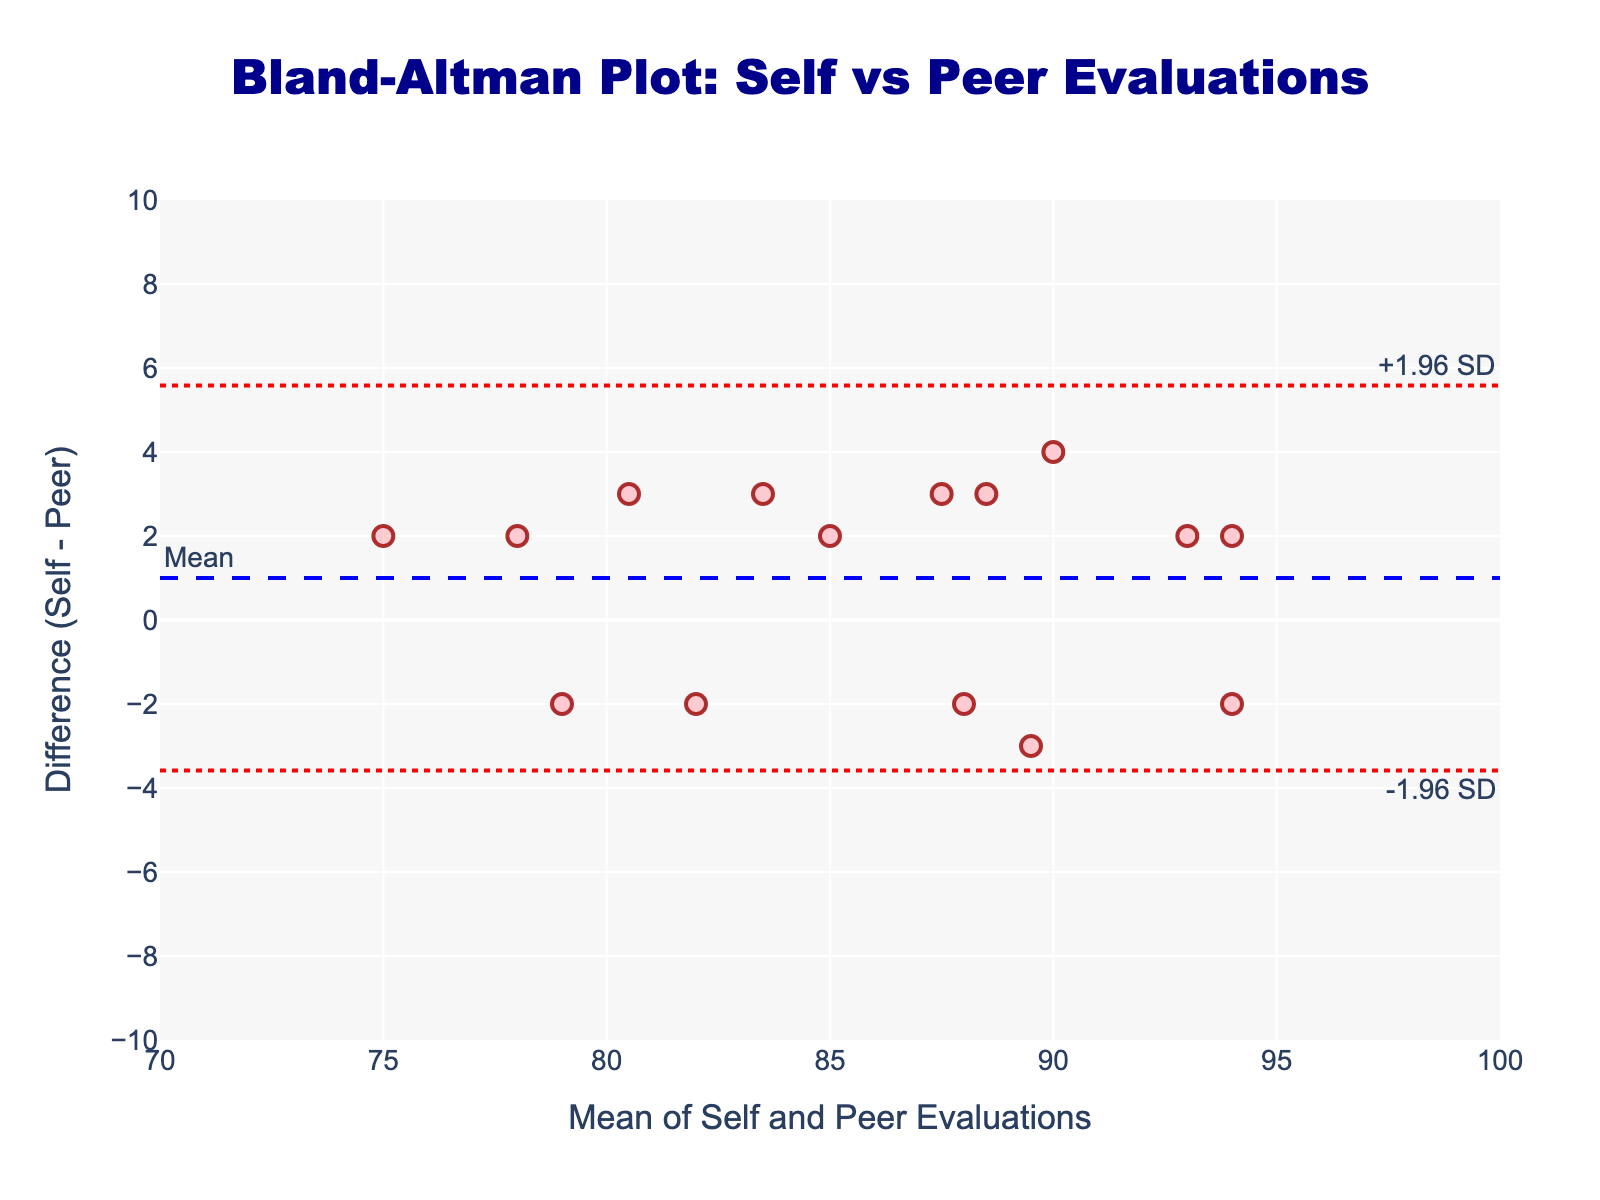What does the title of the plot say? The title is clearly written at the top of the plot, indicating what the plot is about. It says "Bland-Altman Plot: Self vs Peer Evaluations".
Answer: Bland-Altman Plot: Self vs Peer Evaluations What are the axes titles of the plot? The x-axis title is "Mean of Self and Peer Evaluations", and the y-axis title is "Difference (Self - Peer)".
Answer: Mean of Self and Peer Evaluations; Difference (Self - Peer) How many data points are represented in the plot? Each student has one data point in the plot. Since the data list includes 15 students, the plot contains 15 data points.
Answer: 15 What is the mean difference between self-evaluation and peer evaluations? The mean difference is represented by the dashed blue horizontal line, which is labeled "Mean". By looking at the y-value of this line, we find the mean difference is 0.
Answer: 0 What are the upper and lower limits of agreement in the plot? The upper limit of agreement (+1.96 SD) is represented by the upper dashed red line labeled "+1.96 SD", which is approximately 3.8. The lower limit of agreement (-1.96 SD) is represented by the lower dashed red line labeled "-1.96 SD", which is approximately -3.8.
Answer: +3.8 and -3.8 Which data point has the maximum difference between self-evaluation and peer-evaluation? The data point with the highest y-value represents the maximum difference between self-evaluation and peer-evaluation. The highest difference is around 3.
Answer: Around 3 What is the average of self and peer evaluations for Emily Johnson? Emily Johnson's self-evaluation is 85 and her peer evaluation is 82. The average is calculated as (85+82)/2, which equals 83.5.
Answer: 83.5 Of the data points shown, which one has a self-evaluation that is higher than the peer evaluation by the largest margin? The data point with the highest positive value (the highest above the zero line) on the y-axis represents the largest positive difference. This point corresponds to David Rodriguez with a difference of 3 (self-evaluation 88, peer evaluation 91).
Answer: David Rodriguez Which student’s evaluations resulted in a negative value on the y-axis? A negative value on the y-axis indicates the peer evaluation is higher than the self-evaluation. Thus, we need to identify students with such negative differences. Christopher Wilson is one such student with a difference of -2 (self-evaluation 76, peer evaluation 74).
Answer: Christopher Wilson Why might there be limits of agreement shown at +/-1.96 SD? The limits of agreement are there to show the range within which most differences between self and peer evaluations are expected to fall. This statistical interval (mean difference ± 1.96 standard deviations) captures approximately 95% of the differences under the assumption of a normal distribution.
Answer: To capture 95% of the differences 